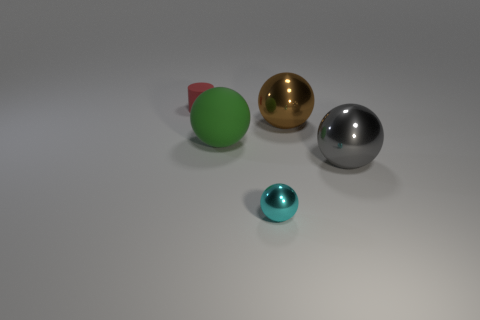Which object appears to be closest to the camera, and what could that signify about its size in relation to the other objects? The turquoise, bowl-shaped object seems closest to the camera, which may imply it's smaller than the other objects, given the perspective; however, without more context, it's difficult to ascertain its exact relative size. 